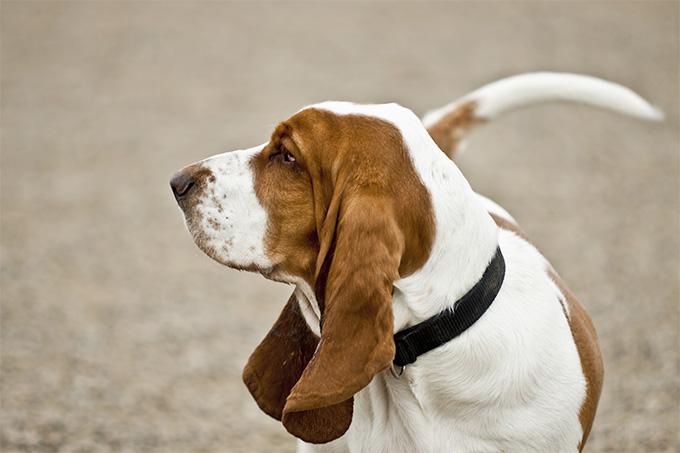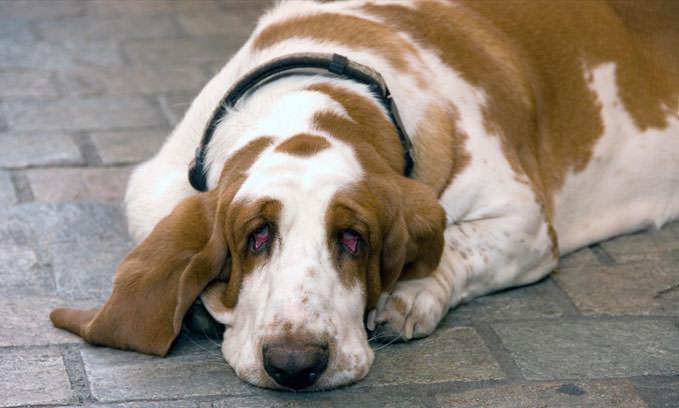The first image is the image on the left, the second image is the image on the right. For the images shown, is this caption "there is a dog lying on the ground" true? Answer yes or no. Yes. 